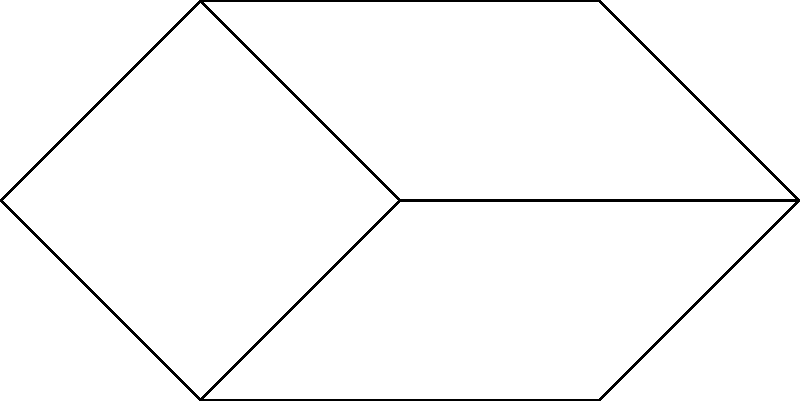In the network of Paula Abdul fan clubs shown above, each vertex represents a city with a fan club, and each edge represents a direct connection between two clubs. If you want to organize a dance event that includes all clubs, what is the minimum number of clubs that need to host simultaneous events to ensure all clubs can participate, assuming each club can only attend an event at a connected city? To solve this problem, we need to find the minimum vertex cover of the graph. A vertex cover is a set of vertices such that every edge in the graph is incident to at least one vertex in the set. The minimum vertex cover represents the smallest number of clubs that need to host events to cover all connections.

Step 1: Analyze the graph structure.
The graph has 7 vertices (clubs) and 9 edges (connections).

Step 2: Identify key vertices.
Vertices 2 and 4 are connected to many other vertices, making them good candidates for the vertex cover.

Step 3: Check if selecting vertices 2 and 4 covers all edges.
- Vertex 2 covers edges: (1-2), (2-3), (2-5)
- Vertex 4 covers edges: (1-4), (3-4), (4-5), (4-6), (4-7)

Step 4: Verify that all edges are covered.
The edge (5-6) is not covered by vertices 2 and 4. We need to add either vertex 5 or 6 to the cover.

Step 5: Choose the vertex that covers more edges.
Vertex 5 covers more edges (5-2, 5-4, 5-6) than vertex 6, so we add vertex 5 to our cover.

Step 6: Final check.
Vertices 2, 4, and 5 cover all edges in the graph.

Therefore, the minimum number of clubs that need to host simultaneous events is 3.
Answer: 3 